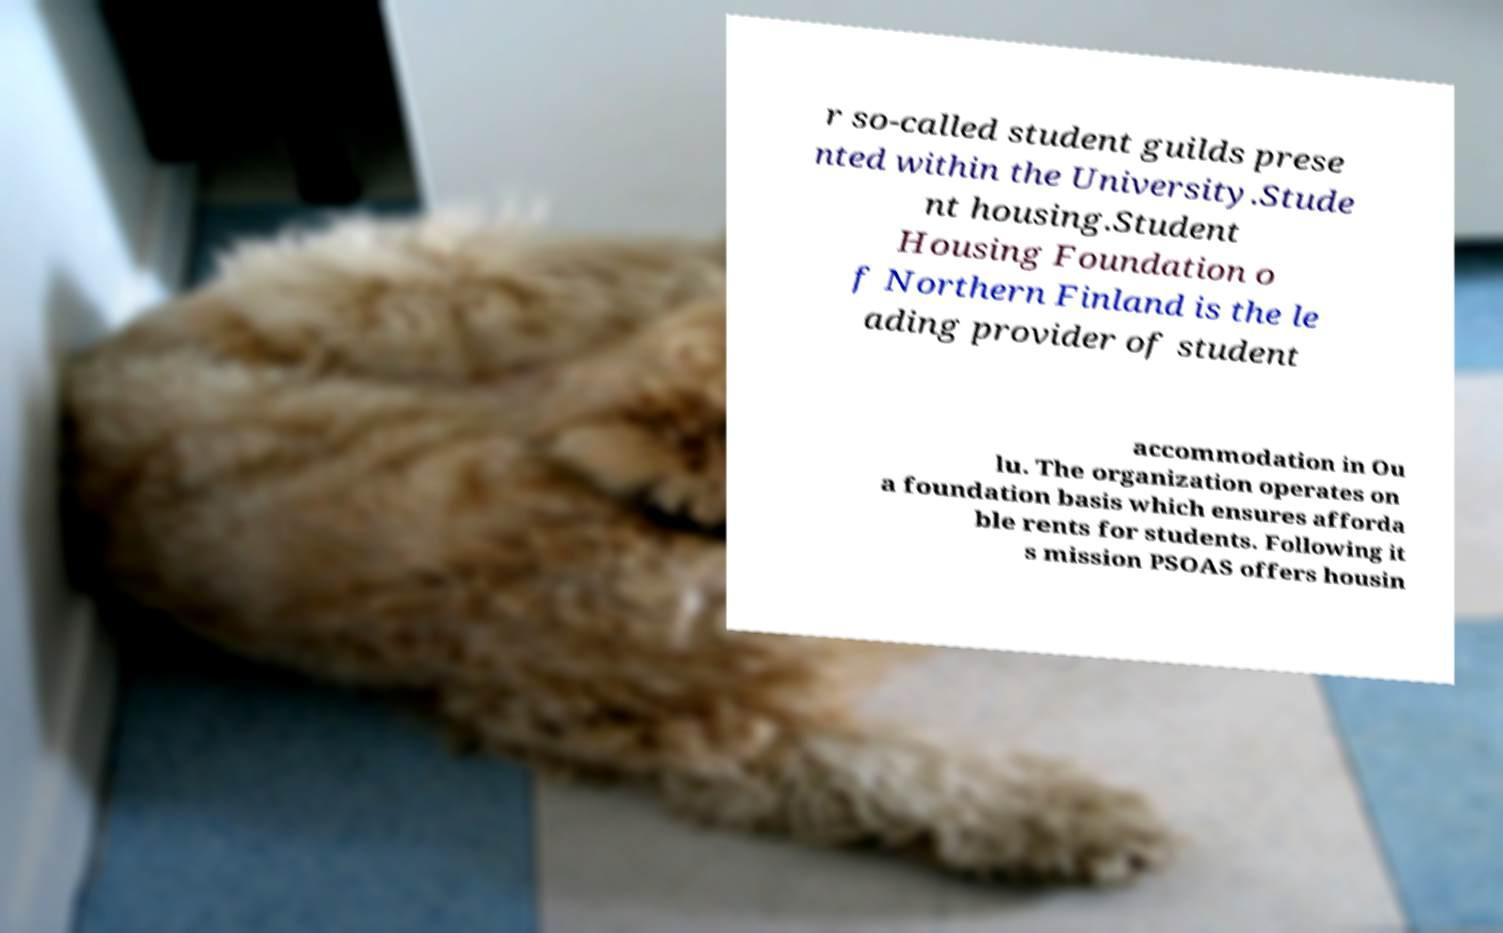Could you extract and type out the text from this image? r so-called student guilds prese nted within the University.Stude nt housing.Student Housing Foundation o f Northern Finland is the le ading provider of student accommodation in Ou lu. The organization operates on a foundation basis which ensures afforda ble rents for students. Following it s mission PSOAS offers housin 